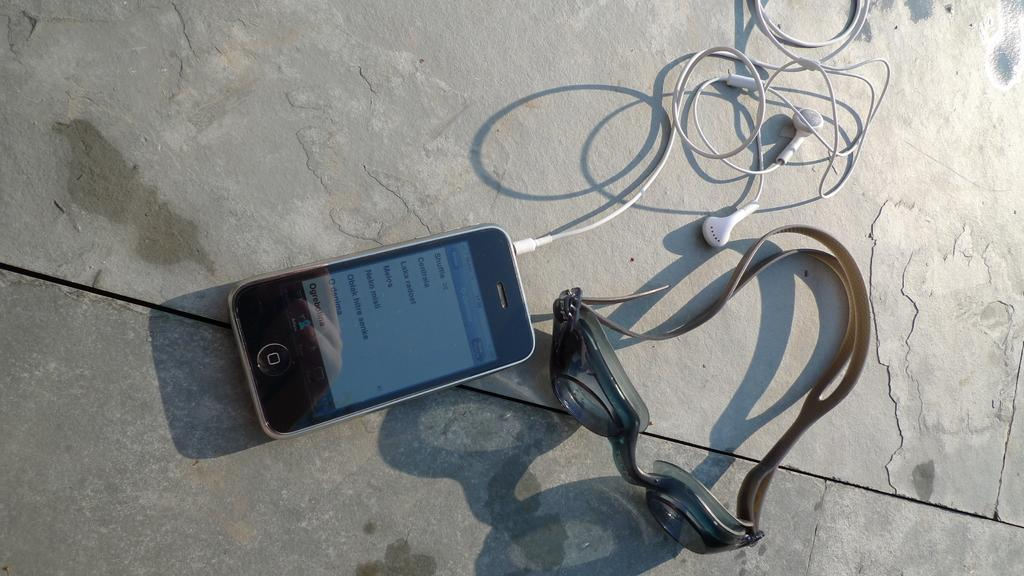Provide a one-sentence caption for the provided image. A phone has a screen that displays the time of 17:26 at the top. 